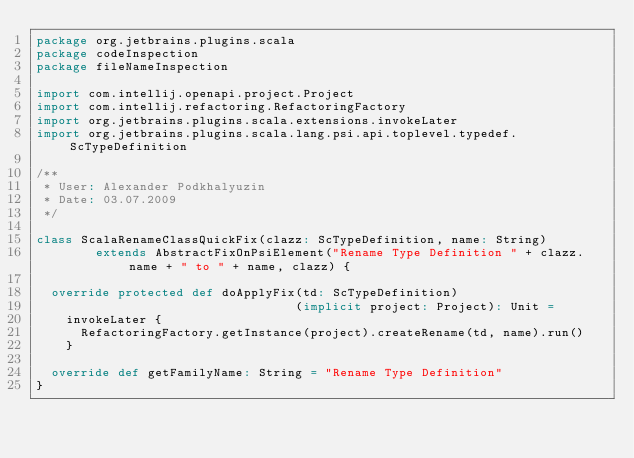Convert code to text. <code><loc_0><loc_0><loc_500><loc_500><_Scala_>package org.jetbrains.plugins.scala
package codeInspection
package fileNameInspection

import com.intellij.openapi.project.Project
import com.intellij.refactoring.RefactoringFactory
import org.jetbrains.plugins.scala.extensions.invokeLater
import org.jetbrains.plugins.scala.lang.psi.api.toplevel.typedef.ScTypeDefinition

/**
 * User: Alexander Podkhalyuzin
 * Date: 03.07.2009
 */

class ScalaRenameClassQuickFix(clazz: ScTypeDefinition, name: String)
        extends AbstractFixOnPsiElement("Rename Type Definition " + clazz.name + " to " + name, clazz) {

  override protected def doApplyFix(td: ScTypeDefinition)
                                   (implicit project: Project): Unit =
    invokeLater {
      RefactoringFactory.getInstance(project).createRename(td, name).run()
    }

  override def getFamilyName: String = "Rename Type Definition"
}</code> 